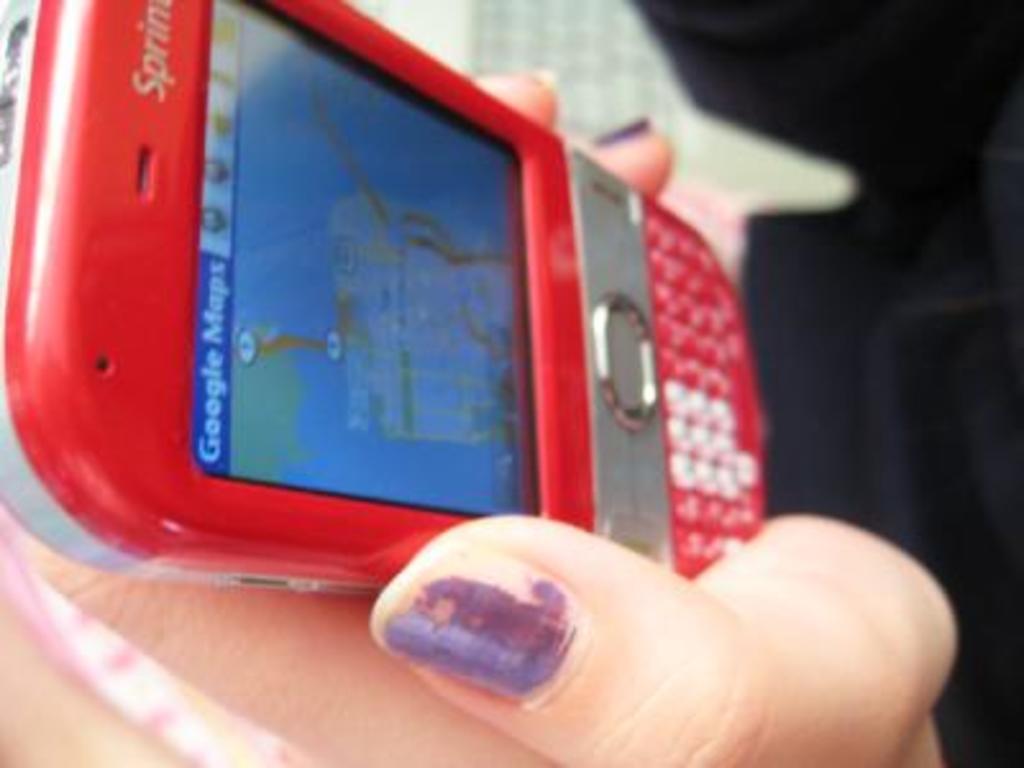What phone company is the phone with?
Your answer should be very brief. Sprint. 